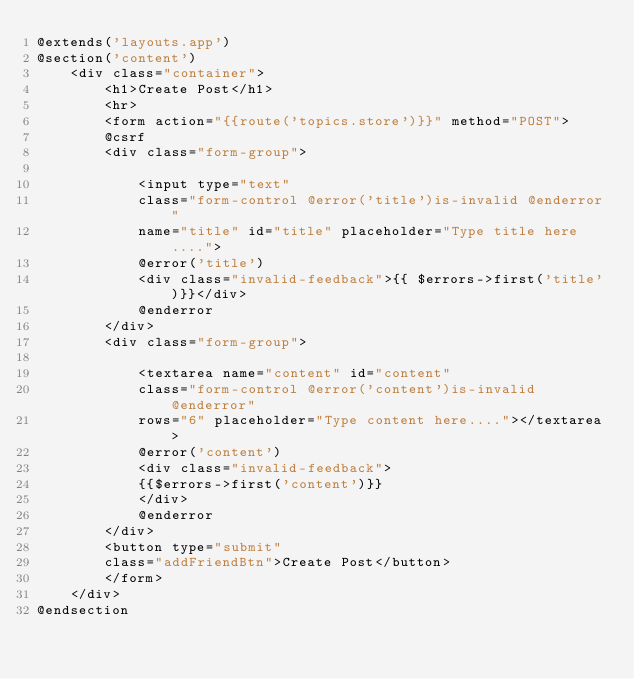Convert code to text. <code><loc_0><loc_0><loc_500><loc_500><_PHP_>@extends('layouts.app')
@section('content')
    <div class="container">
        <h1>Create Post</h1>
        <hr>
        <form action="{{route('topics.store')}}" method="POST">
        @csrf
        <div class="form-group">
            
            <input type="text" 
            class="form-control @error('title')is-invalid @enderror" 
            name="title" id="title" placeholder="Type title here....">
            @error('title')
            <div class="invalid-feedback">{{ $errors->first('title')}}</div>
            @enderror
        </div>
        <div class="form-group">
            
            <textarea name="content" id="content" 
            class="form-control @error('content')is-invalid @enderror" 
            rows="6" placeholder="Type content here...."></textarea>
            @error('content')
            <div class="invalid-feedback">
            {{$errors->first('content')}}
            </div>
            @enderror 
        </div>
        <button type="submit" 
        class="addFriendBtn">Create Post</button>
        </form>
    </div>
@endsection</code> 